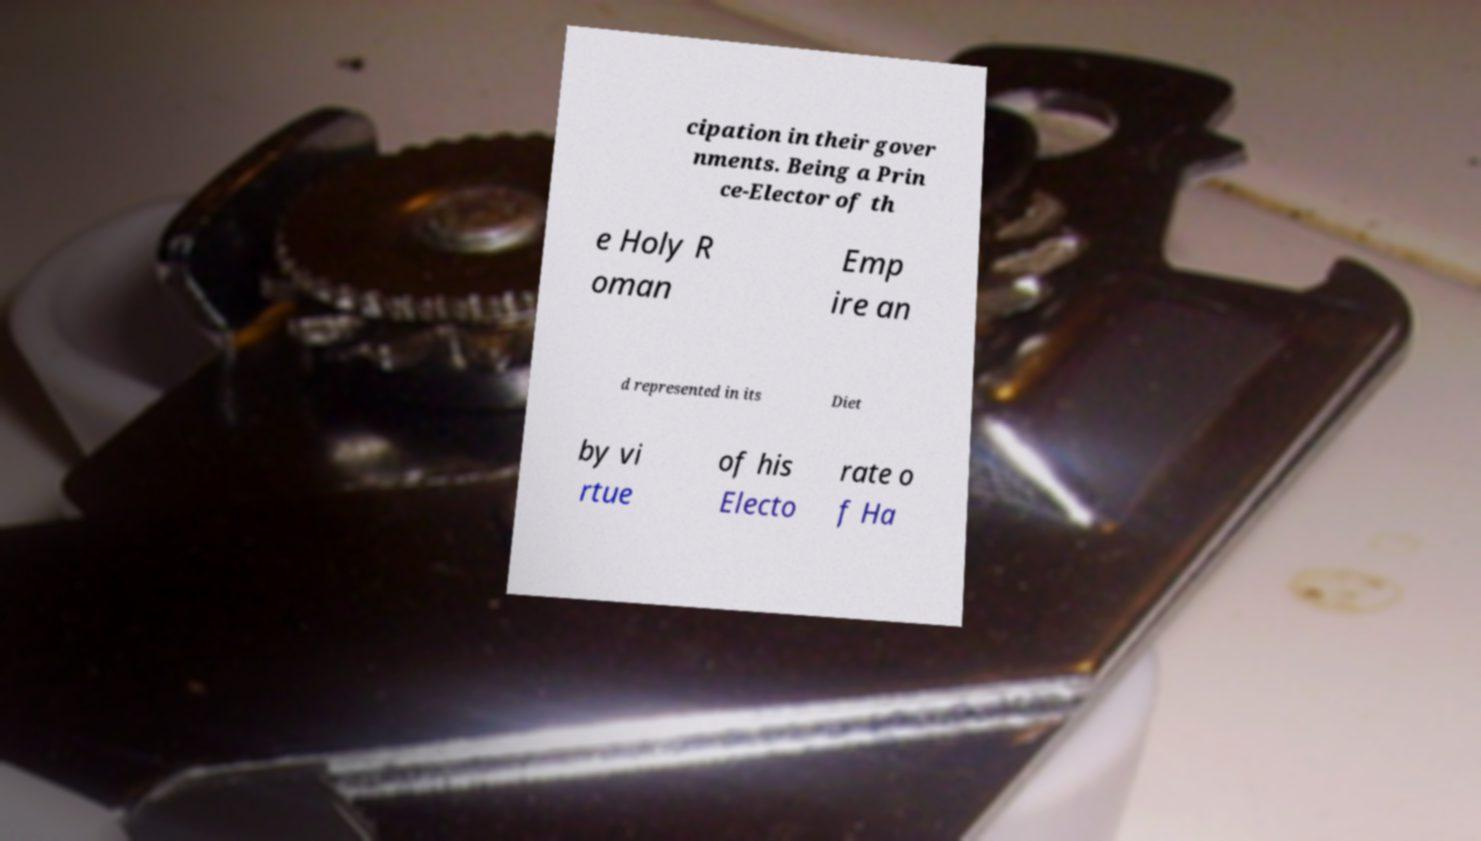Could you extract and type out the text from this image? cipation in their gover nments. Being a Prin ce-Elector of th e Holy R oman Emp ire an d represented in its Diet by vi rtue of his Electo rate o f Ha 